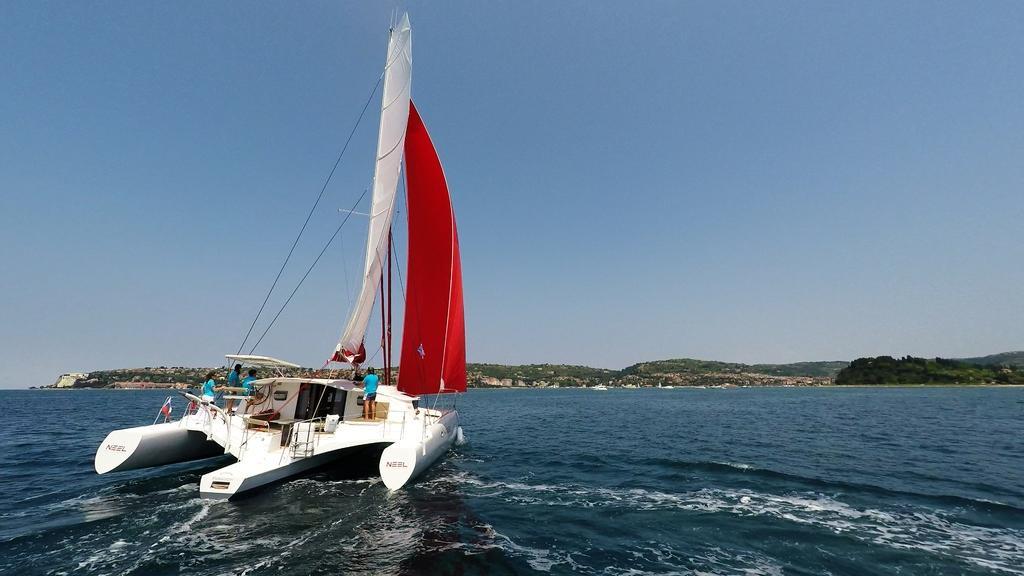How would you summarize this image in a sentence or two? In this image I can see the boat on the water. In the boat I can see the group of people with blue color dresses. In the background I can see the trees, mountains and the sky. 